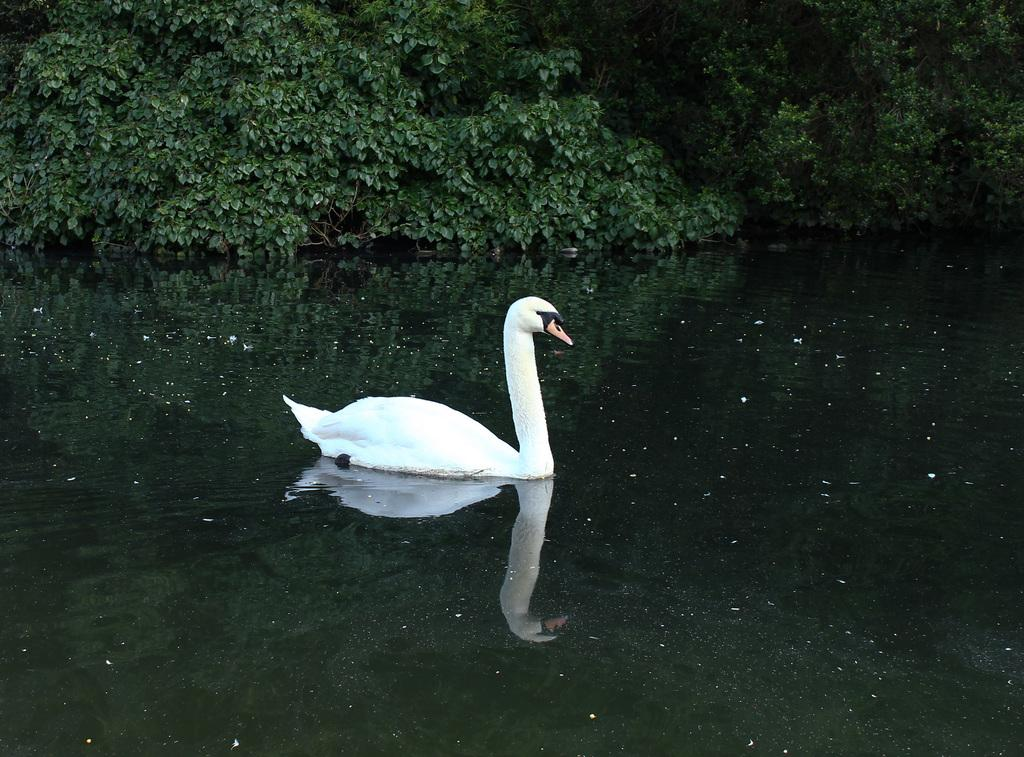What animal is present in the image? There is a swan in the image. What is the swan doing in the image? The swan is swimming on the water. What can be seen in the background of the image? There are leaves of plants in the background of the image. How does the swan control the lumber in the image? There is no lumber present in the image, and swans do not have the ability to control lumber. 